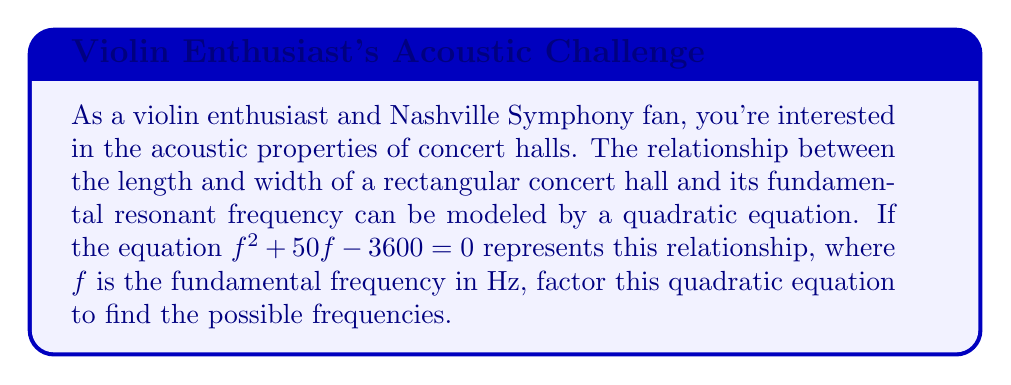Show me your answer to this math problem. To factor this quadratic equation, we'll follow these steps:

1) First, identify the coefficients:
   $a = 1$, $b = 50$, and $c = -3600$

2) We'll use the quadratic formula to find the roots:
   $$f = \frac{-b \pm \sqrt{b^2 - 4ac}}{2a}$$

3) Substitute the values:
   $$f = \frac{-50 \pm \sqrt{50^2 - 4(1)(-3600)}}{2(1)}$$

4) Simplify under the square root:
   $$f = \frac{-50 \pm \sqrt{2500 + 14400}}{2} = \frac{-50 \pm \sqrt{16900}}{2}$$

5) Simplify further:
   $$f = \frac{-50 \pm 130}{2}$$

6) This gives us two solutions:
   $$f = \frac{-50 + 130}{2} = 40$$ or $$f = \frac{-50 - 130}{2} = -90$$

7) Since frequency can't be negative, we discard the negative solution.

8) Now we can factor the original equation:
   $$f^2 + 50f - 3600 = (f - 40)(f + 90) = 0$$

This factored form represents the relationship between the concert hall dimensions and its fundamental resonant frequency.
Answer: $(f - 40)(f + 90) = 0$ 